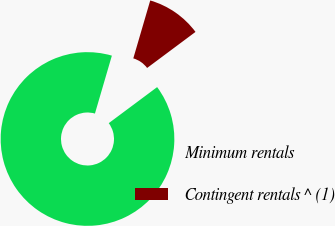Convert chart to OTSL. <chart><loc_0><loc_0><loc_500><loc_500><pie_chart><fcel>Minimum rentals<fcel>Contingent rentals ^ (1)<nl><fcel>89.72%<fcel>10.28%<nl></chart> 